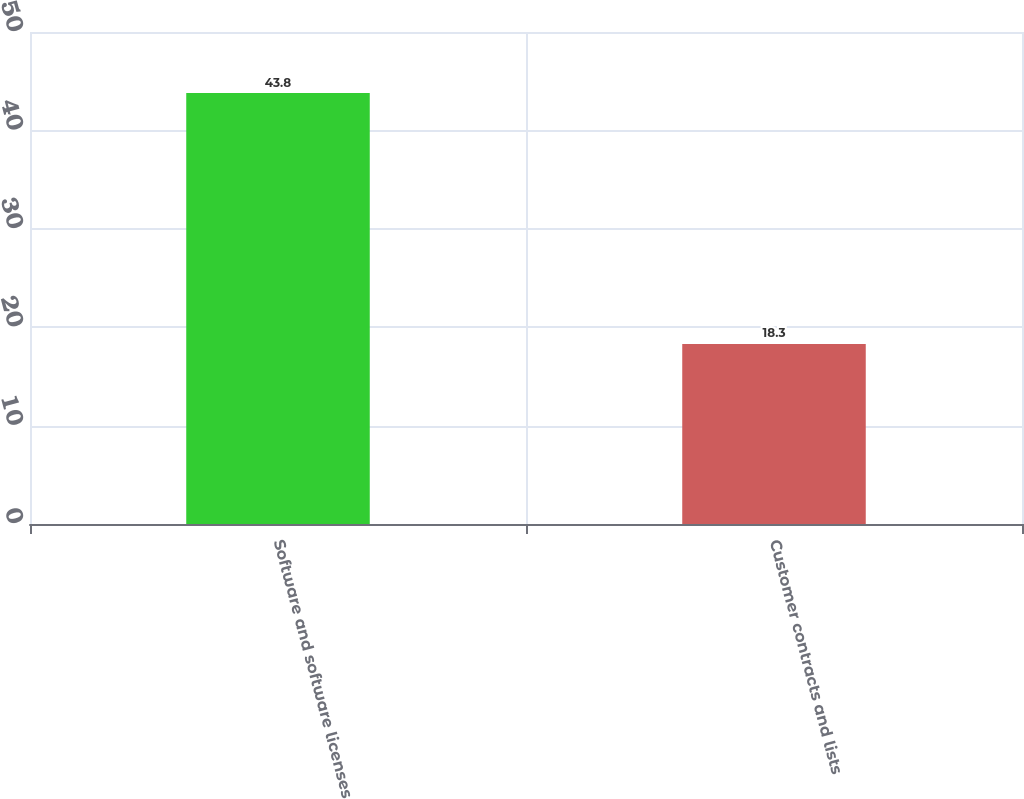<chart> <loc_0><loc_0><loc_500><loc_500><bar_chart><fcel>Software and software licenses<fcel>Customer contracts and lists<nl><fcel>43.8<fcel>18.3<nl></chart> 